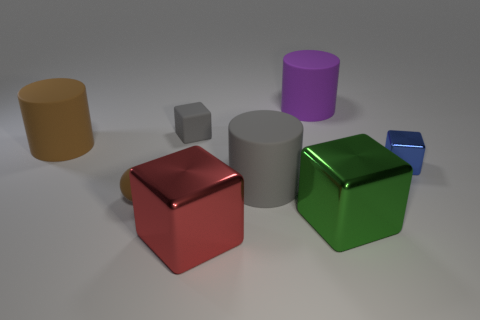The brown thing in front of the shiny cube that is right of the green object is made of what material?
Give a very brief answer. Rubber. Do the brown matte sphere that is in front of the purple object and the small blue cube have the same size?
Offer a very short reply. Yes. Is there a shiny object of the same color as the rubber sphere?
Keep it short and to the point. No. What number of things are small matte things that are behind the blue thing or metallic things that are to the left of the big gray matte cylinder?
Keep it short and to the point. 2. Is the number of gray matte blocks behind the large purple thing less than the number of large rubber objects that are to the left of the blue block?
Provide a succinct answer. Yes. Does the small ball have the same material as the red thing?
Offer a very short reply. No. How big is the block that is both in front of the gray matte cylinder and to the right of the large purple rubber cylinder?
Provide a short and direct response. Large. There is a purple matte thing that is the same size as the gray cylinder; what shape is it?
Your answer should be compact. Cylinder. The gray cylinder that is on the left side of the metal block behind the gray thing to the right of the large red cube is made of what material?
Your response must be concise. Rubber. There is a metallic object that is behind the matte ball; is its shape the same as the big object in front of the green thing?
Make the answer very short. Yes. 